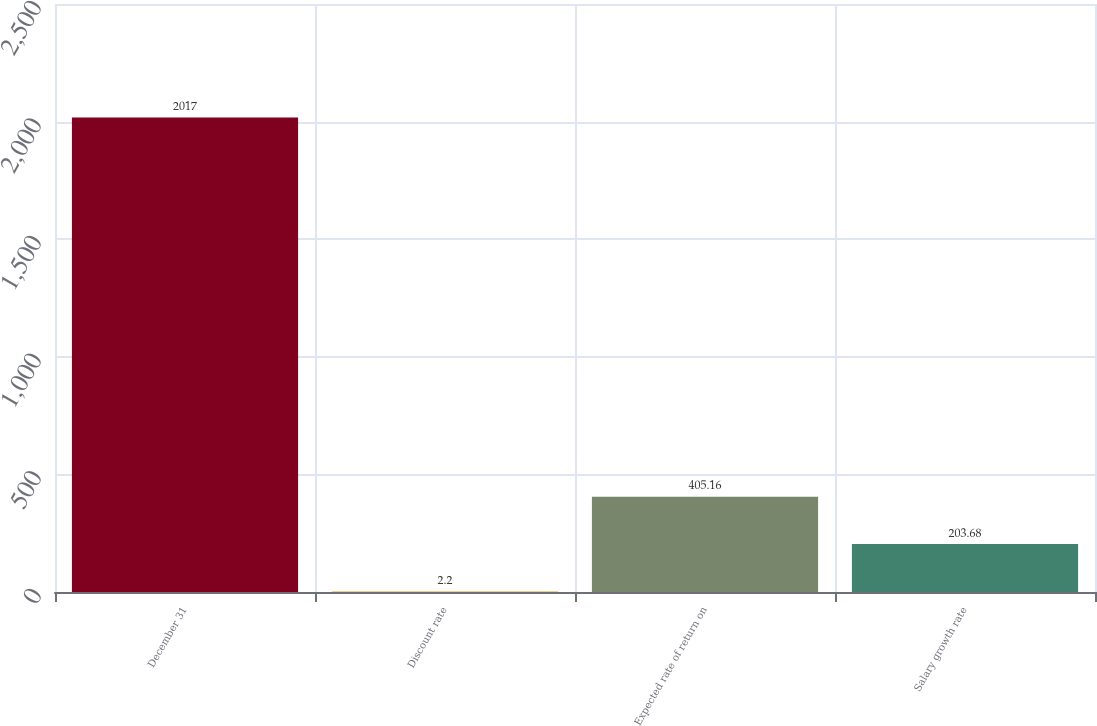Convert chart to OTSL. <chart><loc_0><loc_0><loc_500><loc_500><bar_chart><fcel>December 31<fcel>Discount rate<fcel>Expected rate of return on<fcel>Salary growth rate<nl><fcel>2017<fcel>2.2<fcel>405.16<fcel>203.68<nl></chart> 